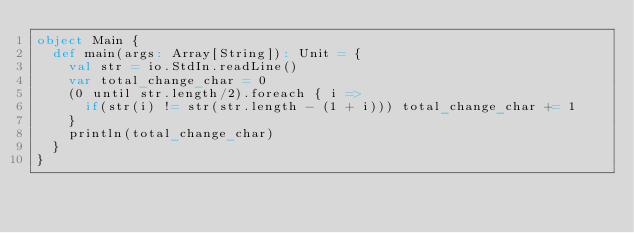<code> <loc_0><loc_0><loc_500><loc_500><_Scala_>object Main {
  def main(args: Array[String]): Unit = {
    val str = io.StdIn.readLine()
    var total_change_char = 0
    (0 until str.length/2).foreach { i =>
      if(str(i) != str(str.length - (1 + i))) total_change_char += 1
    }
    println(total_change_char)
  }
}</code> 